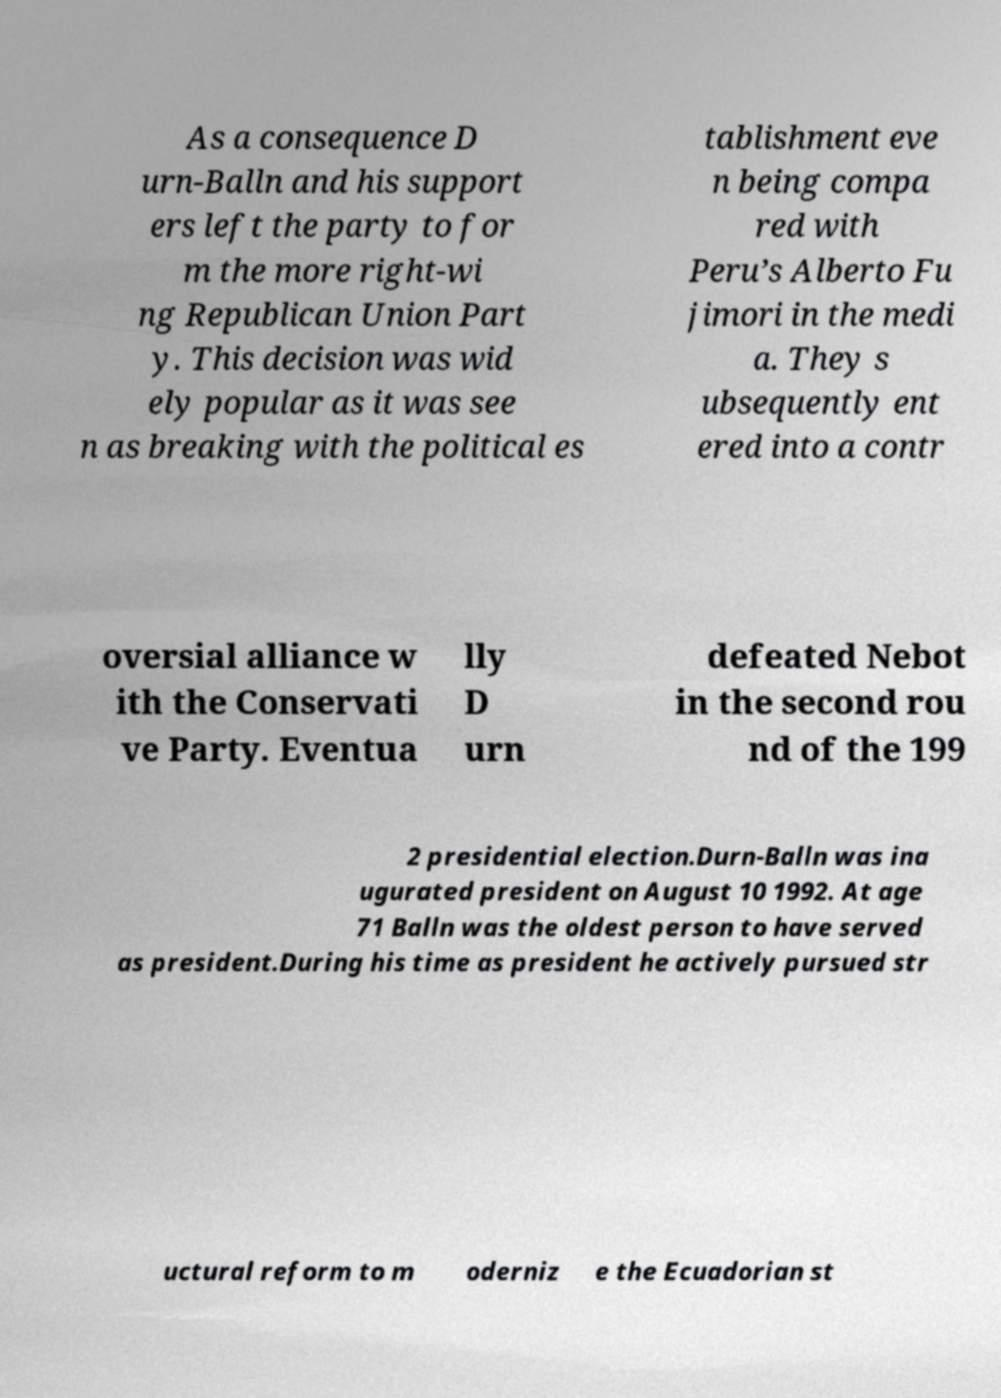Could you extract and type out the text from this image? As a consequence D urn-Balln and his support ers left the party to for m the more right-wi ng Republican Union Part y. This decision was wid ely popular as it was see n as breaking with the political es tablishment eve n being compa red with Peru’s Alberto Fu jimori in the medi a. They s ubsequently ent ered into a contr oversial alliance w ith the Conservati ve Party. Eventua lly D urn defeated Nebot in the second rou nd of the 199 2 presidential election.Durn-Balln was ina ugurated president on August 10 1992. At age 71 Balln was the oldest person to have served as president.During his time as president he actively pursued str uctural reform to m oderniz e the Ecuadorian st 